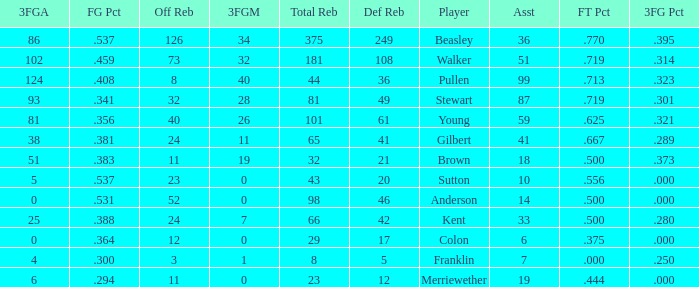What is the total number of offensive rebounds for players with under 65 total rebounds, 5 defensive rebounds, and under 7 assists? 0.0. 